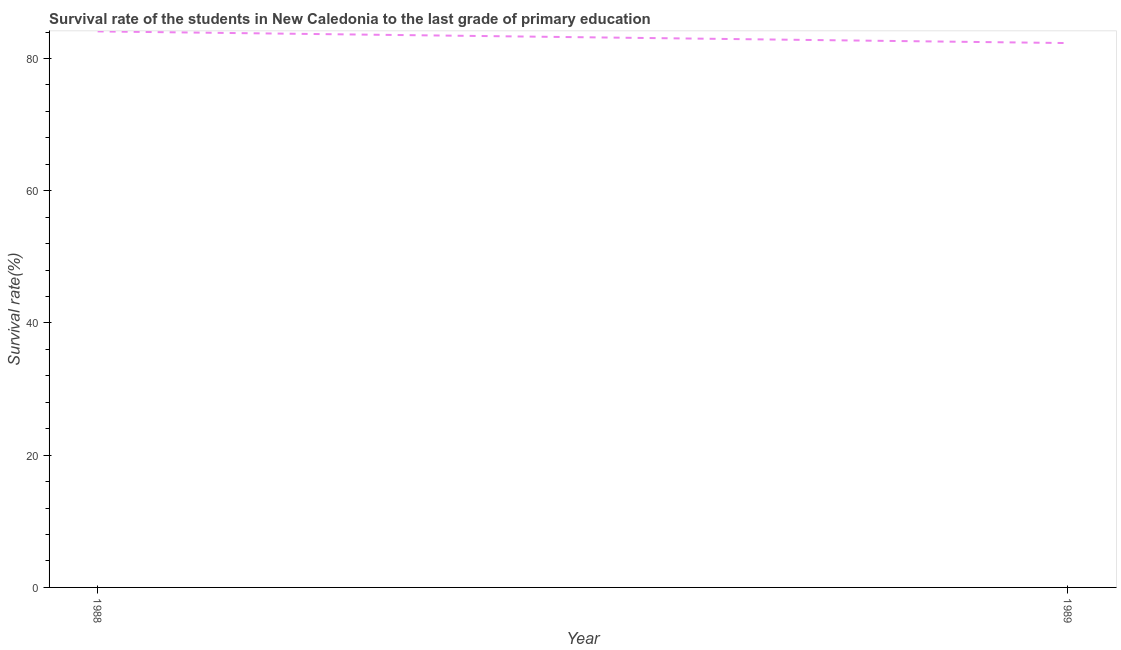What is the survival rate in primary education in 1989?
Your answer should be compact. 82.34. Across all years, what is the maximum survival rate in primary education?
Ensure brevity in your answer.  84.1. Across all years, what is the minimum survival rate in primary education?
Give a very brief answer. 82.34. In which year was the survival rate in primary education minimum?
Make the answer very short. 1989. What is the sum of the survival rate in primary education?
Keep it short and to the point. 166.44. What is the difference between the survival rate in primary education in 1988 and 1989?
Ensure brevity in your answer.  1.77. What is the average survival rate in primary education per year?
Offer a terse response. 83.22. What is the median survival rate in primary education?
Keep it short and to the point. 83.22. What is the ratio of the survival rate in primary education in 1988 to that in 1989?
Offer a terse response. 1.02. Does the survival rate in primary education monotonically increase over the years?
Your response must be concise. No. How many lines are there?
Ensure brevity in your answer.  1. Are the values on the major ticks of Y-axis written in scientific E-notation?
Offer a very short reply. No. Does the graph contain any zero values?
Offer a terse response. No. What is the title of the graph?
Provide a succinct answer. Survival rate of the students in New Caledonia to the last grade of primary education. What is the label or title of the X-axis?
Keep it short and to the point. Year. What is the label or title of the Y-axis?
Offer a very short reply. Survival rate(%). What is the Survival rate(%) of 1988?
Give a very brief answer. 84.1. What is the Survival rate(%) of 1989?
Give a very brief answer. 82.34. What is the difference between the Survival rate(%) in 1988 and 1989?
Keep it short and to the point. 1.77. 